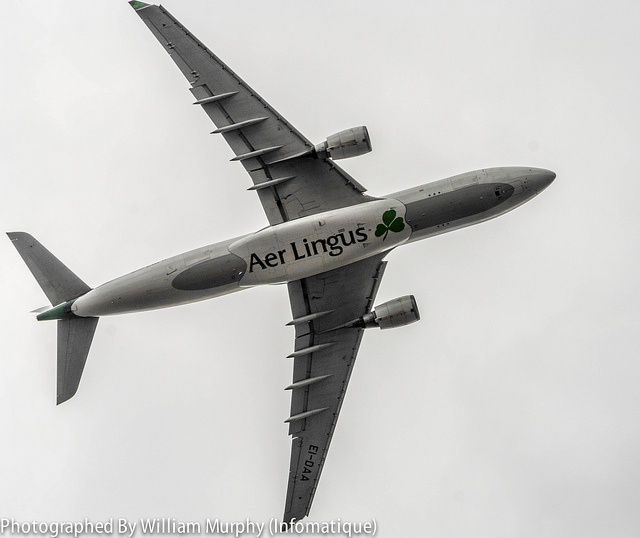Describe the objects in this image and their specific colors. I can see a airplane in white, gray, black, darkgray, and lightgray tones in this image. 